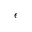Convert formula to latex. <formula><loc_0><loc_0><loc_500><loc_500>\epsilon</formula> 